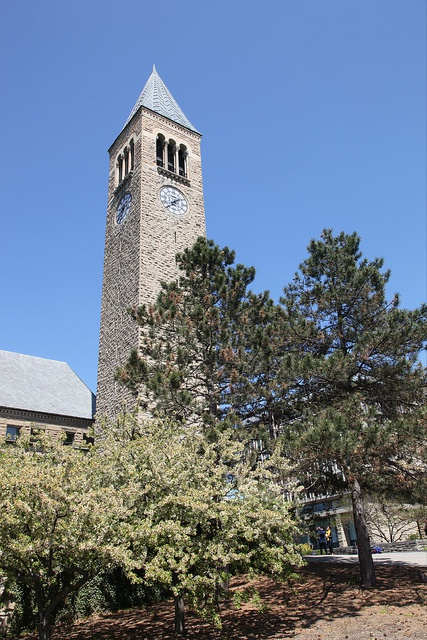Describe the objects in this image and their specific colors. I can see clock in gray, lightgray, and darkgray tones and clock in gray, darkgray, and black tones in this image. 